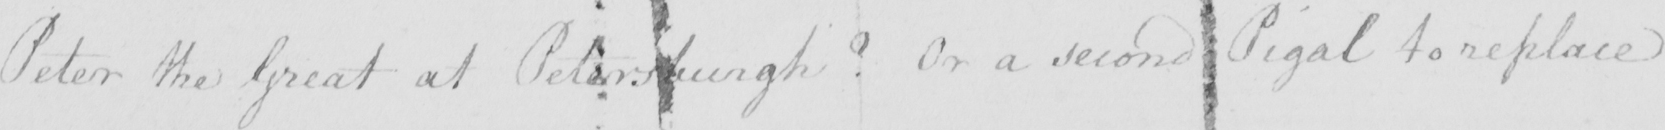Can you tell me what this handwritten text says? Peter the Great at Petersburgh ?  Or a second Pigal to replace 